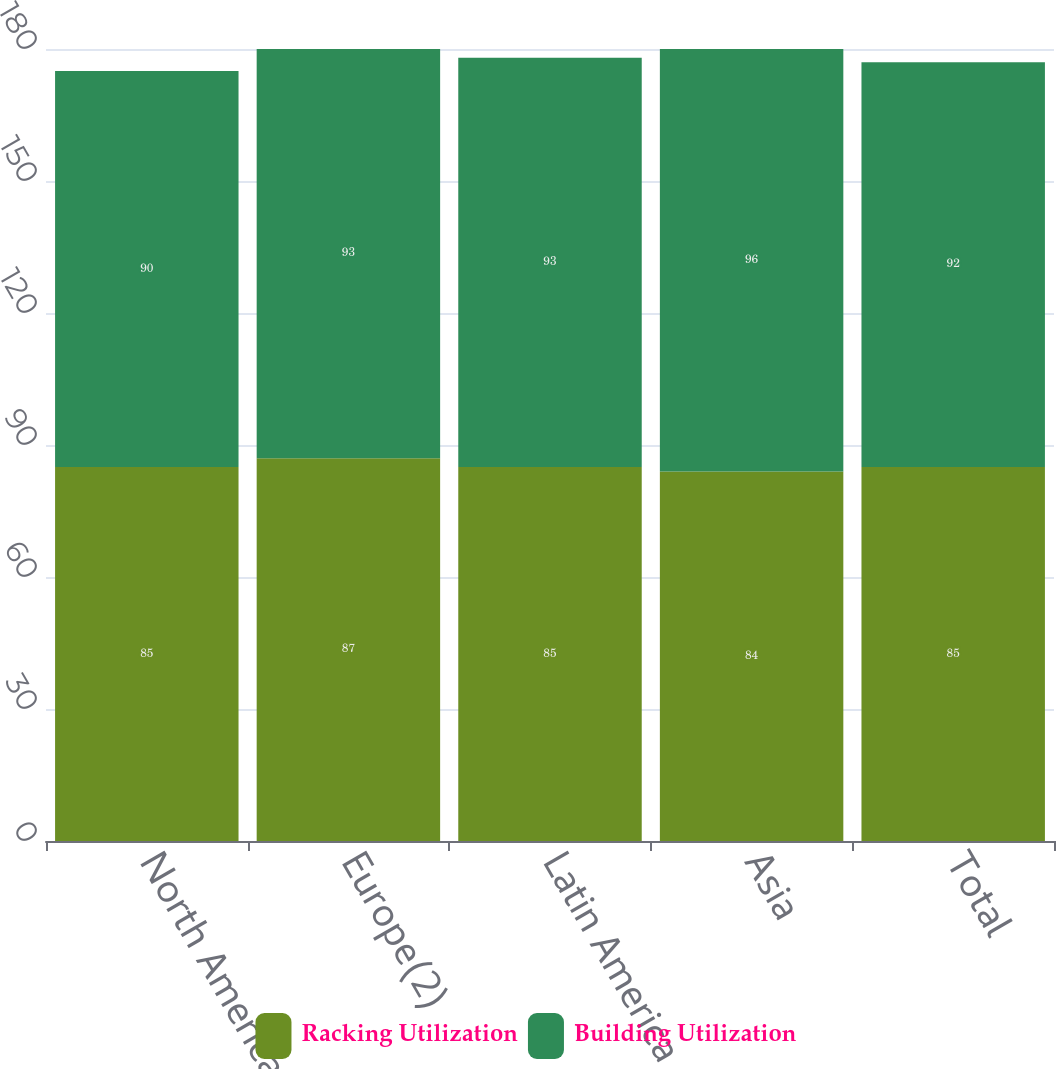Convert chart to OTSL. <chart><loc_0><loc_0><loc_500><loc_500><stacked_bar_chart><ecel><fcel>North America<fcel>Europe(2)<fcel>Latin America<fcel>Asia<fcel>Total<nl><fcel>Racking Utilization<fcel>85<fcel>87<fcel>85<fcel>84<fcel>85<nl><fcel>Building Utilization<fcel>90<fcel>93<fcel>93<fcel>96<fcel>92<nl></chart> 